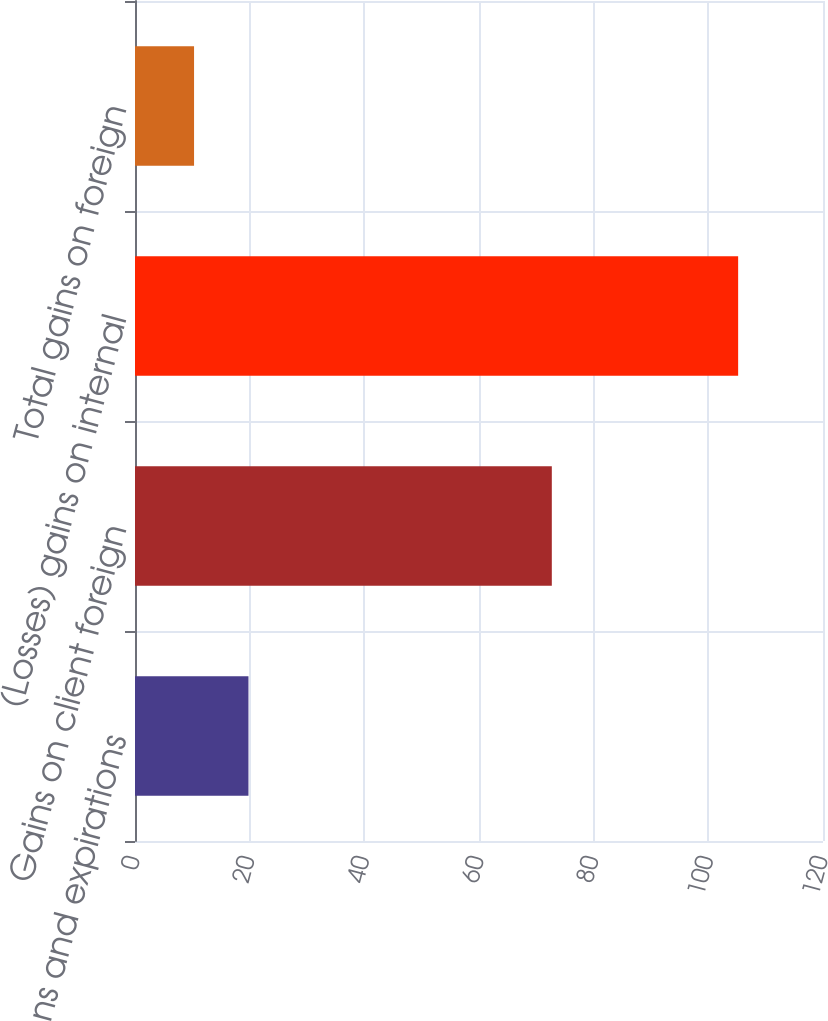Convert chart to OTSL. <chart><loc_0><loc_0><loc_500><loc_500><bar_chart><fcel>Cancellations and expirations<fcel>Gains on client foreign<fcel>(Losses) gains on internal<fcel>Total gains on foreign<nl><fcel>19.79<fcel>72.7<fcel>105.2<fcel>10.3<nl></chart> 